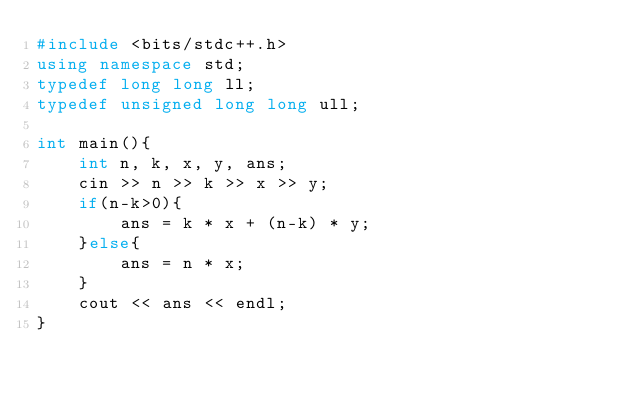<code> <loc_0><loc_0><loc_500><loc_500><_C++_>#include <bits/stdc++.h>
using namespace std;
typedef long long ll;
typedef unsigned long long ull;

int main(){
    int n, k, x, y, ans;
    cin >> n >> k >> x >> y;
    if(n-k>0){
        ans = k * x + (n-k) * y;
    }else{
        ans = n * x;
    }
    cout << ans << endl;
}
</code> 